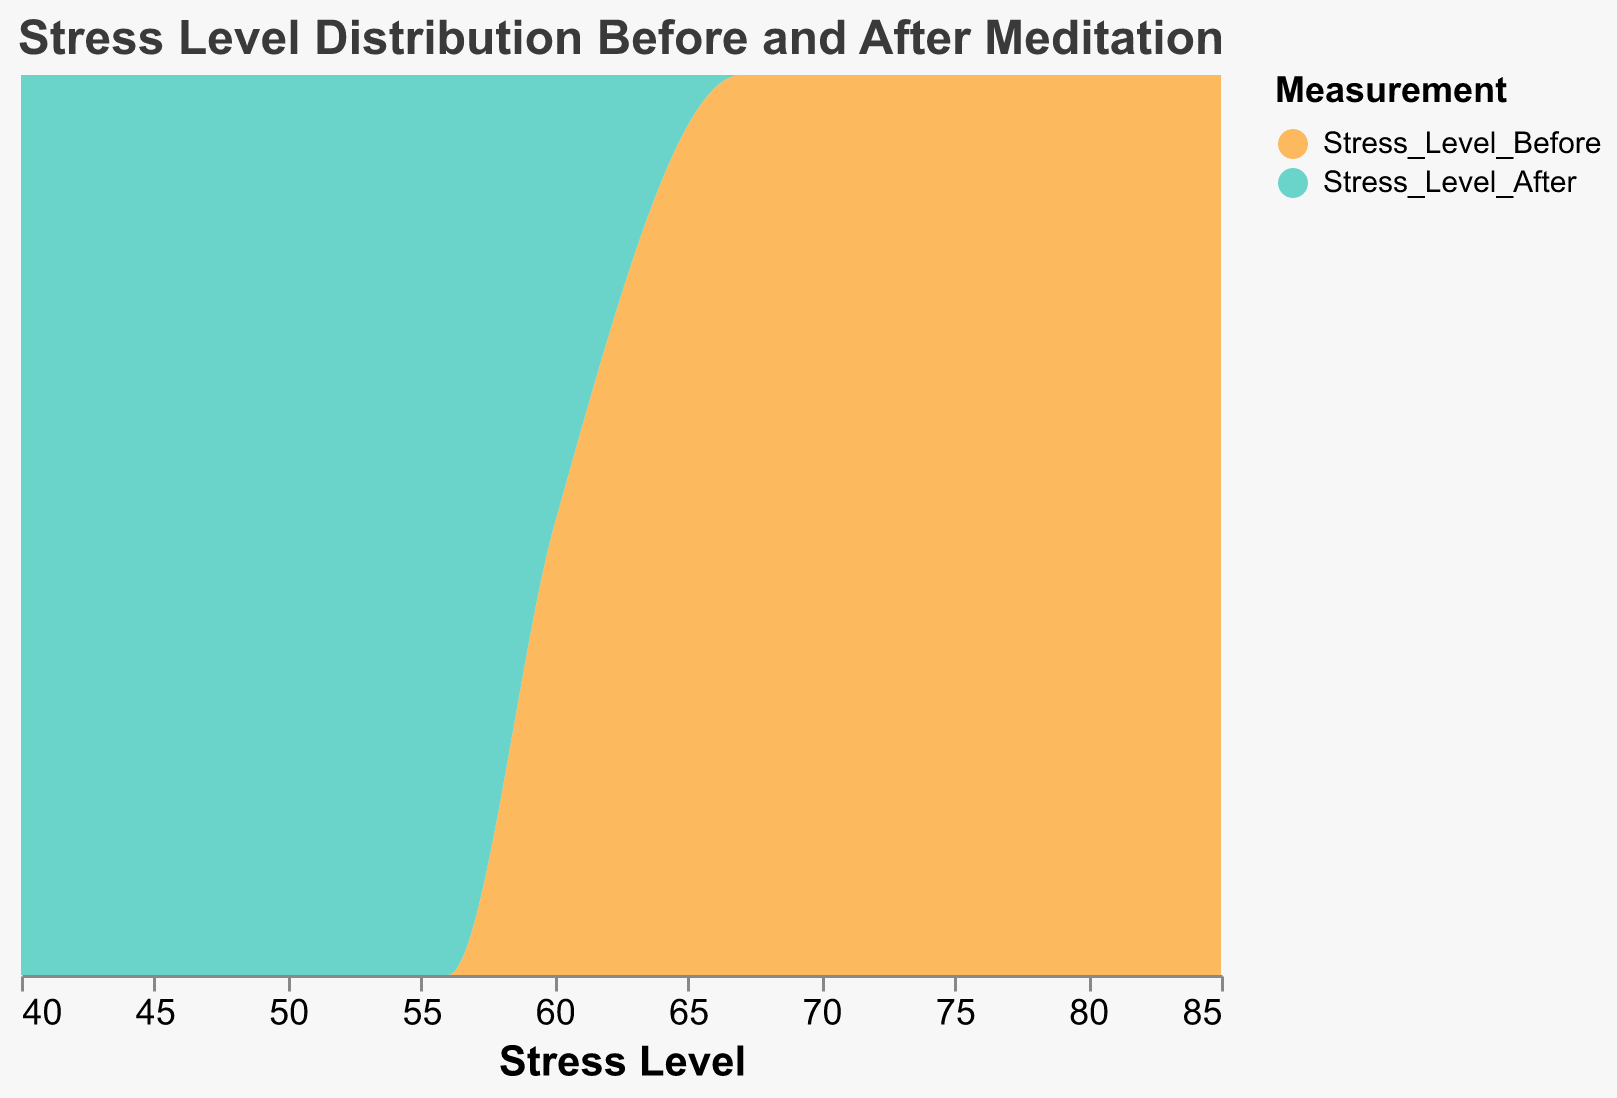What is the title of the plot? The title is displayed at the top of the figure in a larger and bold font. It describes the content of the plot.
Answer: Stress Level Distribution Before and After Meditation Which color represents stress levels before meditation? The legend indicates that the color designated for stress levels before meditation is an orange shade.
Answer: Orange Which color represents stress levels after meditation? The legend shows that the color assigned for stress levels after meditation is a light blue shade.
Answer: Light blue Are the stress levels before and after meditation plotted on the same axis? Both measurements (before and after stress levels) are plotted along the x-axis indicating the range of stress levels.
Answer: Yes How does the plot show the distribution of stress levels? The plot uses area marks that are filled under a curve to show the distribution density of stress levels before and after meditation.
Answer: Area marks Is the average stress level higher before or after meditation for all techniques combined? By observing the density curves, the distribution of stress levels before meditation appears shifted towards higher values compared to after meditation, with peaks indicating higher averages before meditation.
Answer: Higher before meditation Which measurement has a wider distribution? The curves’ spread along the x-axis indicates the range of stress levels. The orange curve (before meditation) appears more spread out.
Answer: Stress levels before meditation What stress level range has the highest density after meditation? The light blue curve reaches its highest peak, indicating the range where most data points lie, around the 45-50 stress level mark.
Answer: Around 45-50 Does the plot visually indicate if meditation is effective in reducing stress levels? The density curves show that stress levels generally shift to lower values after meditation sessions, indicating effectiveness.
Answer: Yes 